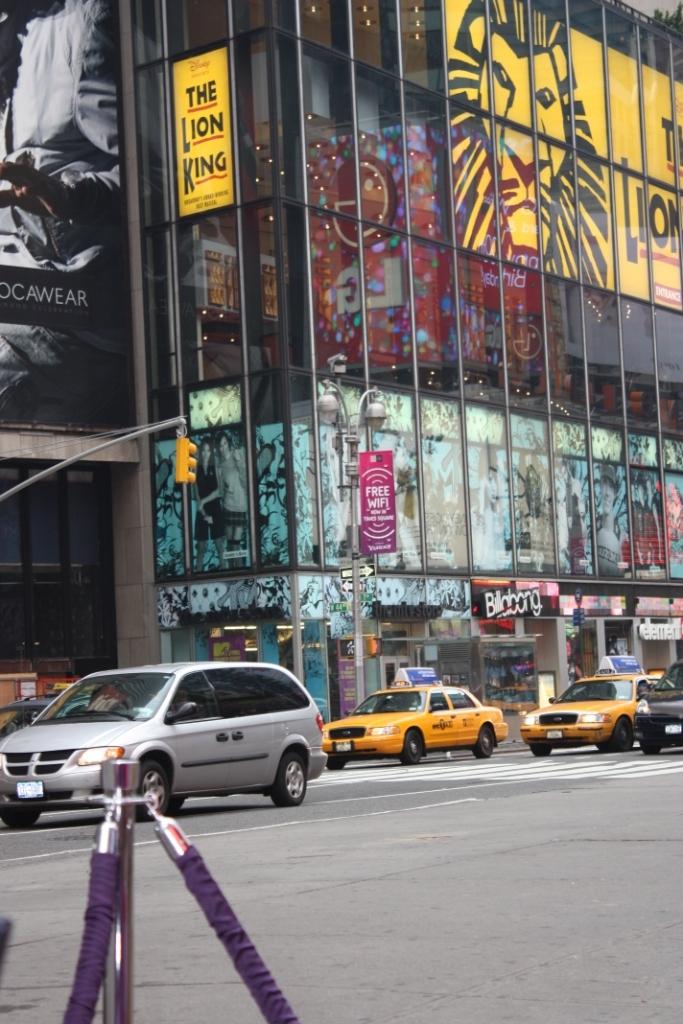What show is playing?
Keep it short and to the point. The lion king. Who is advertising on the sign?
Make the answer very short. The lion king. 